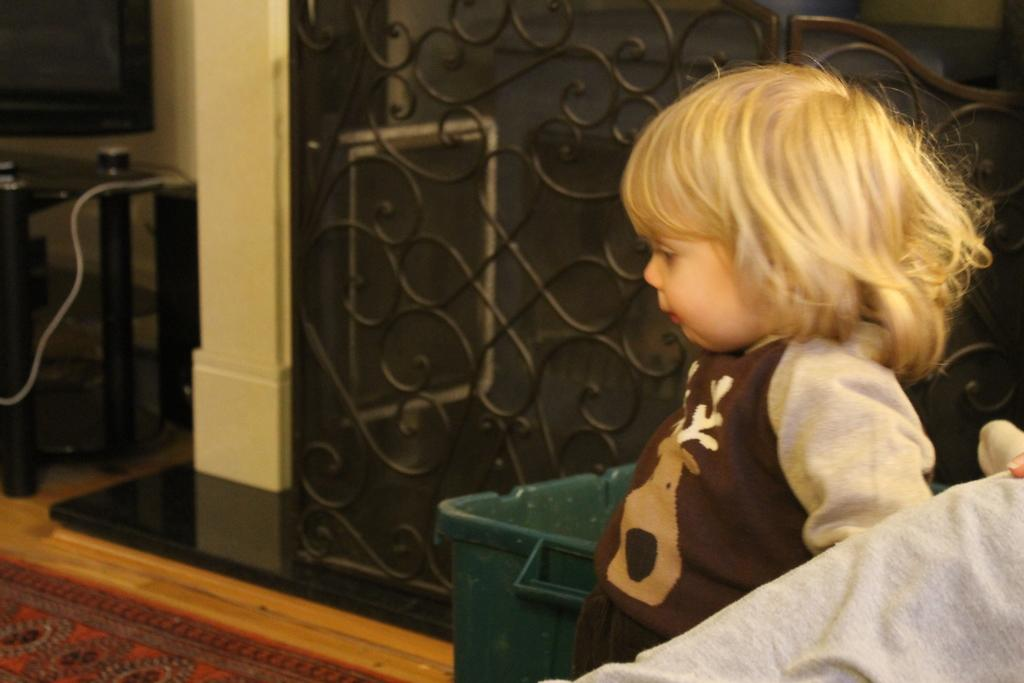What is the main subject of the image? The main subject of the image is a kid standing. Where is the kid standing in the image? The kid is standing on the floor. What type of flooring is visible in the image? There is a carpet in the image. What other objects can be seen in the image? There are grills and a bin in the image. What type of polish is the kid applying to the yak in the image? There is no yak or polish present in the image; it features a kid standing on a carpet with grills and a bin nearby. 